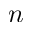<formula> <loc_0><loc_0><loc_500><loc_500>n</formula> 